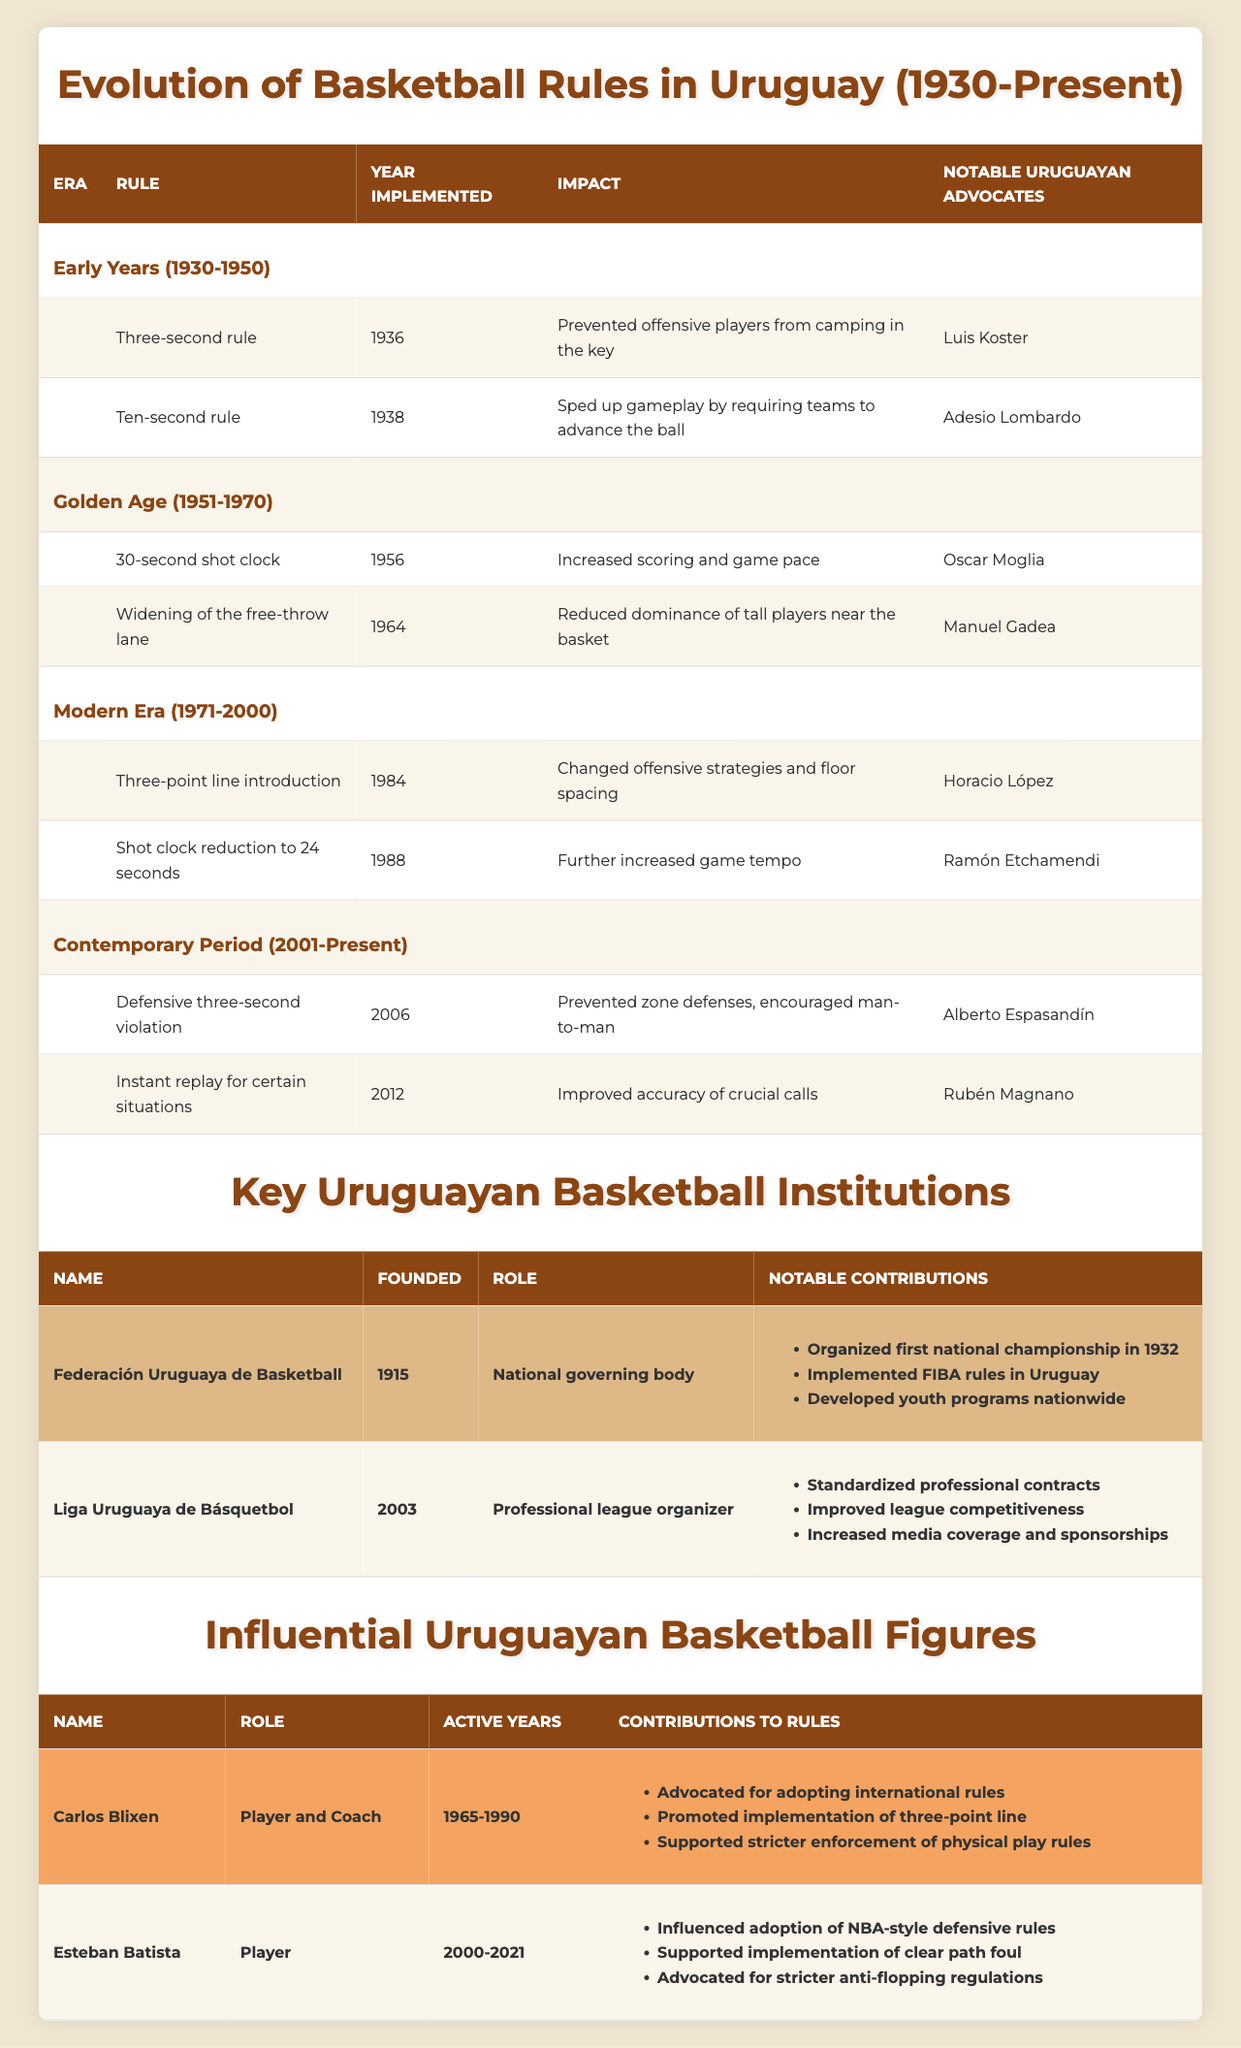What year was the three-second rule implemented in Uruguay? The three-second rule was implemented in 1936, as stated in the table under the 'Early Years (1930-1950)' era.
Answer: 1936 Who advocated for the implementation of the three-point line in Uruguay? The table indicates that Horacio López was the notable advocate for the implementation of the three-point line in 1984, during the 'Modern Era (1971-2000)'.
Answer: Horacio López What impact did the 30-second shot clock have on the game? According to the table, the 30-second shot clock increased scoring and game pace, implemented in 1956 during the 'Golden Age (1951-1970)'.
Answer: Increased scoring and game pace List one notable contribution of the Federación Uruguaya de Basketball. The table shows that one notable contribution of the Federación Uruguaya de Basketball is that they organized the first national championship in 1932.
Answer: Organized the first national championship in 1932 In which era was the defensive three-second violation introduced? The defensive three-second violation was introduced in the 'Contemporary Period (2001-Present)', specifically in 2006, as shown in the table.
Answer: Contemporary Period (2001-Present) How many major changes were implemented during the 'Modern Era (1971-2000)'? The table states there were two major changes during the 'Modern Era (1971-2000)': the introduction of the three-point line and shot clock reduction.
Answer: 2 Which basketball figure's contributions included advocating for stricter enforcement of physical play rules? The table indicates that Carlos Blixen was the basketball figure who advocated for stricter enforcement of physical play rules among other contributions.
Answer: Carlos Blixen Was the ten-second rule implemented before or after the three-second rule? The ten-second rule was implemented in 1938, which is after the three-second rule implemented in 1936, based on the timelines provided in the table.
Answer: After Count the number of notable contributions listed for Liga Uruguaya de Básquetbol. The table lists three notable contributions for Liga Uruguaya de Básquetbol, which are standardized professional contracts, improved league competitiveness, and increased media coverage and sponsorships.
Answer: 3 What was the impact of the widening of the free-throw lane? The table states that the widening of the free-throw lane reduced the dominance of tall players near the basket, indicating a significant strategic change in the game.
Answer: Reduced dominance of tall players near the basket Which rule was implemented in 2012, and what was its impact? The table shows that instant replay for certain situations was implemented in 2012, improving the accuracy of crucial calls, thereby ensuring fairness in the game.
Answer: Improved accuracy of crucial calls Identify two rules that were implemented in the Golden Age (1951-1970). According to the table, two rules implemented in the Golden Age include the 30-second shot clock in 1956 and the widening of the free-throw lane in 1964.
Answer: 30-second shot clock, widening of the free-throw lane Which influential figure was active during the years 2000 to 2021? The table states that Esteban Batista was the influential figure active during the years 2000 to 2021.
Answer: Esteban Batista What major change was proposed by Alberto Espasandín? The table indicates that Alberto Espasandín advocated for the defensive three-second violation in 2006, representing a significant change in gameplay strategy.
Answer: Defensive three-second violation How did the three-point line introduction change the game strategy? The introduction of the three-point line in 1984 changed offensive strategies and floor spacing, as noted in the 'Modern Era (1971-2000)' section of the table.
Answer: Changed offensive strategies and floor spacing 